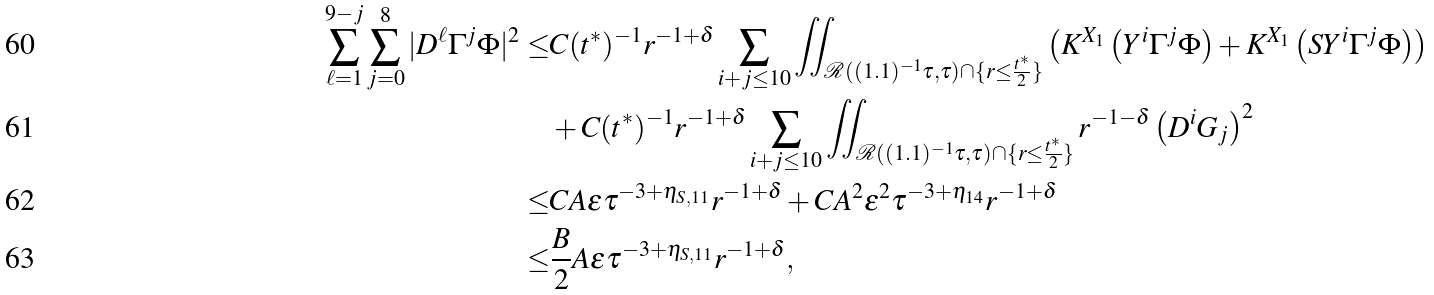<formula> <loc_0><loc_0><loc_500><loc_500>\sum _ { \ell = 1 } ^ { 9 - j } \sum _ { j = 0 } ^ { 8 } | D ^ { \ell } \Gamma ^ { j } \Phi | ^ { 2 } \leq & C ( t ^ { * } ) ^ { - 1 } r ^ { - 1 + \delta } \sum _ { i + j \leq 1 0 } \iint _ { \mathcal { R } ( ( 1 . 1 ) ^ { - 1 } \tau , \tau ) \cap \{ r \leq \frac { t ^ { * } } { 2 } \} } \left ( K ^ { X _ { 1 } } \left ( Y ^ { i } \Gamma ^ { j } \Phi \right ) + K ^ { X _ { 1 } } \left ( S Y ^ { i } \Gamma ^ { j } \Phi \right ) \right ) \\ & + C ( t ^ { * } ) ^ { - 1 } r ^ { - 1 + \delta } \sum _ { i + j \leq 1 0 } \iint _ { \mathcal { R } ( ( 1 . 1 ) ^ { - 1 } \tau , \tau ) \cap \{ r \leq \frac { t ^ { * } } { 2 } \} } r ^ { - 1 - \delta } \left ( D ^ { i } G _ { j } \right ) ^ { 2 } \\ \leq & C A \epsilon \tau ^ { - 3 + \eta _ { S , 1 1 } } r ^ { - 1 + \delta } + C A ^ { 2 } \epsilon ^ { 2 } \tau ^ { - 3 + \eta _ { 1 4 } } r ^ { - 1 + \delta } \\ \leq & \frac { B } { 2 } A \epsilon \tau ^ { - 3 + \eta _ { S , 1 1 } } r ^ { - 1 + \delta } ,</formula> 